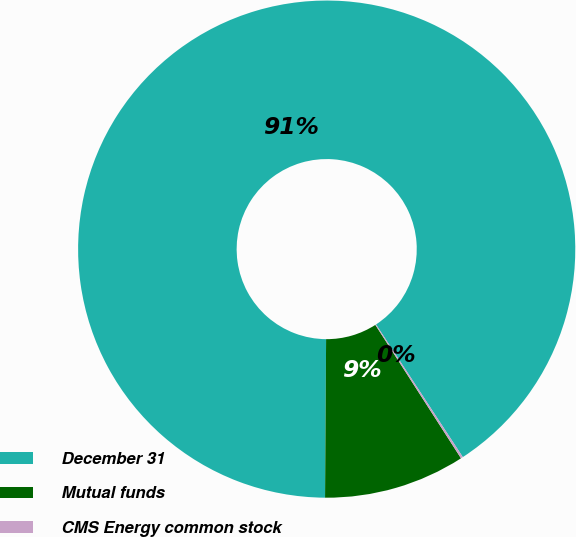Convert chart to OTSL. <chart><loc_0><loc_0><loc_500><loc_500><pie_chart><fcel>December 31<fcel>Mutual funds<fcel>CMS Energy common stock<nl><fcel>90.68%<fcel>9.19%<fcel>0.14%<nl></chart> 